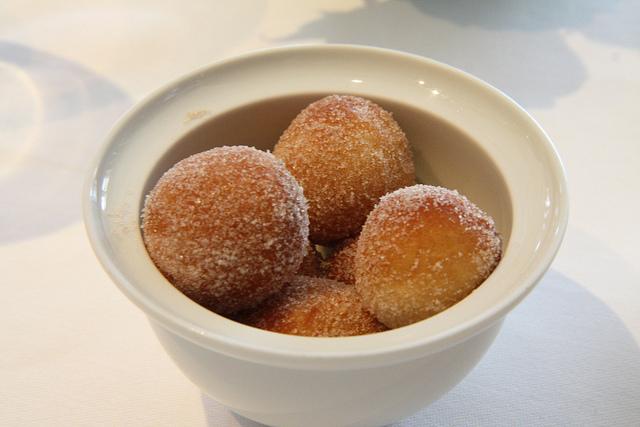Has this food been eaten yet?
Keep it brief. No. What is the white stuff on the food?
Be succinct. Sugar. What food is this?
Be succinct. Donuts. 